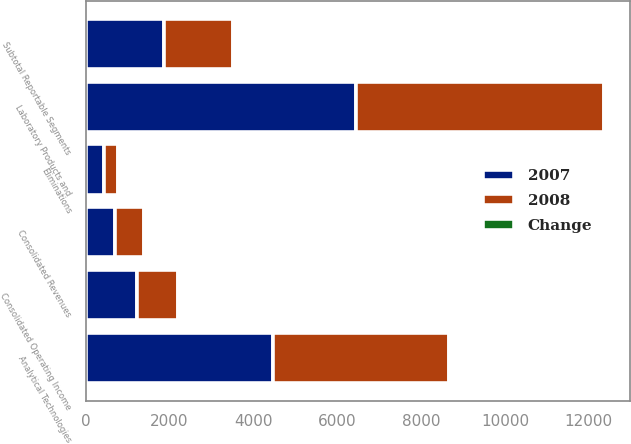<chart> <loc_0><loc_0><loc_500><loc_500><stacked_bar_chart><ecel><fcel>Analytical Technologies<fcel>Laboratory Products and<fcel>Eliminations<fcel>Consolidated Revenues<fcel>Subtotal Reportable Segments<fcel>Consolidated Operating Income<nl><fcel>2007<fcel>4471.2<fcel>6453.3<fcel>426.5<fcel>700.45<fcel>1869.1<fcel>1229.4<nl><fcel>2008<fcel>4181.7<fcel>5911.1<fcel>346.4<fcel>700.45<fcel>1636.9<fcel>974.4<nl><fcel>Change<fcel>7<fcel>9<fcel>23<fcel>8<fcel>14<fcel>26<nl></chart> 